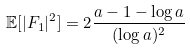Convert formula to latex. <formula><loc_0><loc_0><loc_500><loc_500>\mathbb { E } [ | F _ { 1 } | ^ { 2 } ] = 2 \frac { a - 1 - \log { a } } { ( \log { a } ) ^ { 2 } }</formula> 